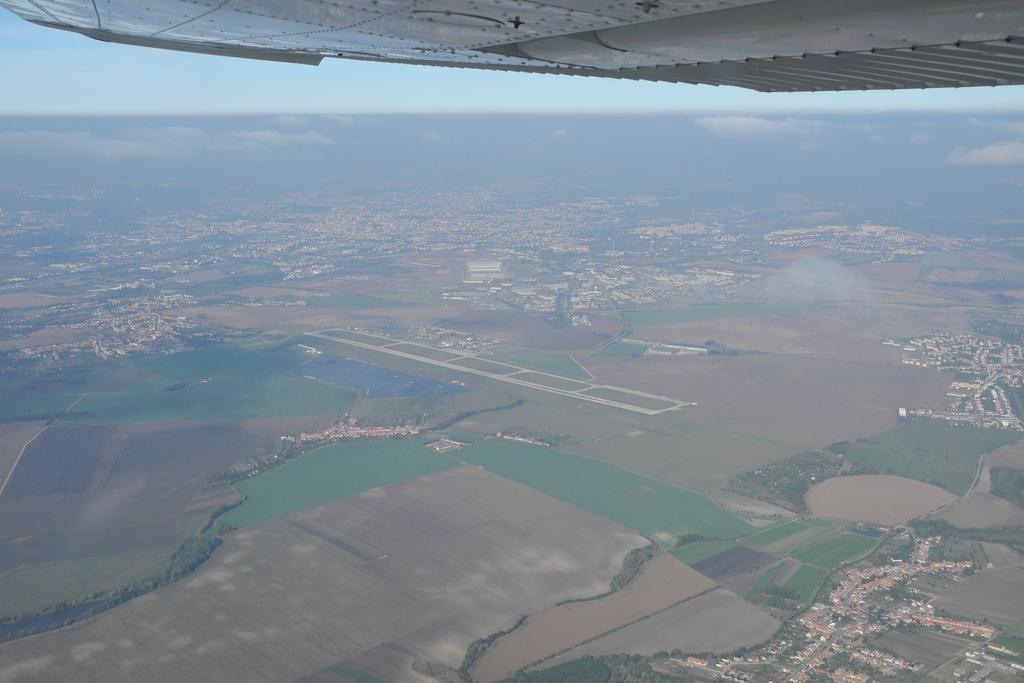In one or two sentences, can you explain what this image depicts? In this image I can see this picture has been taken from top view. I can also see the sky in background. 